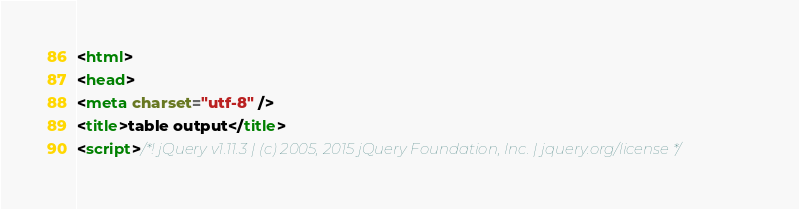<code> <loc_0><loc_0><loc_500><loc_500><_HTML_><html>
<head>
<meta charset="utf-8" />
<title>table output</title>
<script>/*! jQuery v1.11.3 | (c) 2005, 2015 jQuery Foundation, Inc. | jquery.org/license */</code> 